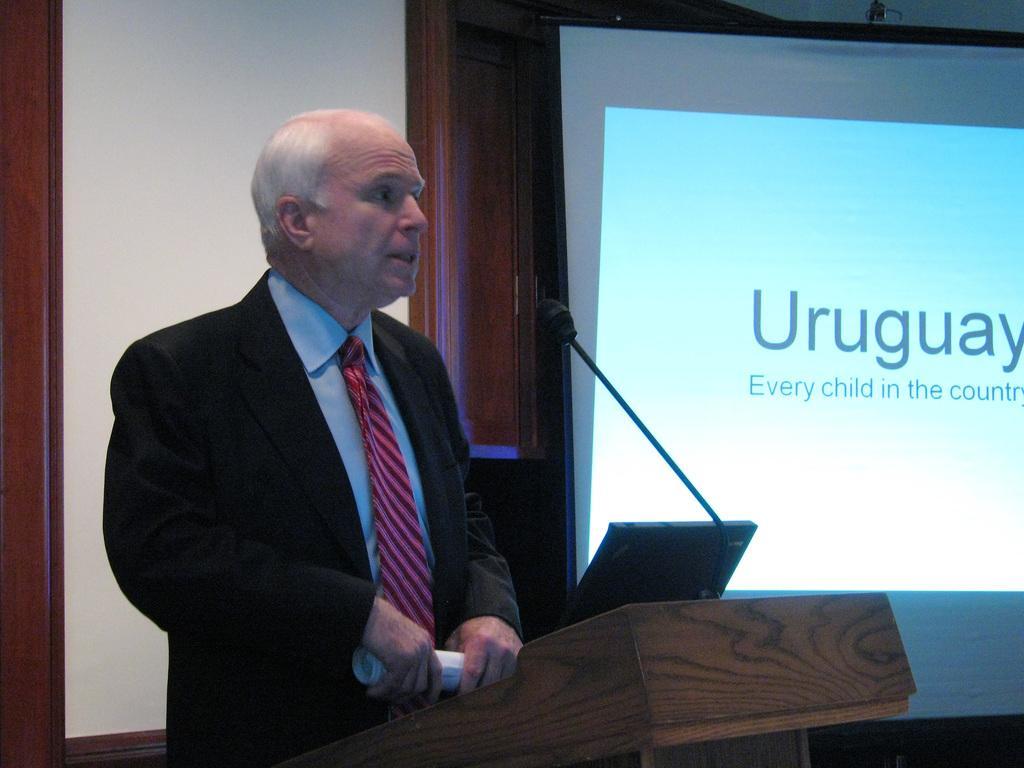How would you summarize this image in a sentence or two? In this picture a man standing and holding papers in his hand and looks like a laptop and a microphone on the podium. I can see a projector screen displaying some text. 